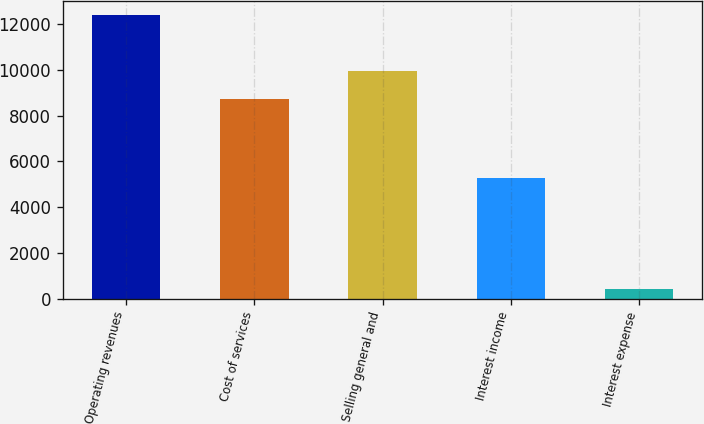<chart> <loc_0><loc_0><loc_500><loc_500><bar_chart><fcel>Operating revenues<fcel>Cost of services<fcel>Selling general and<fcel>Interest income<fcel>Interest expense<nl><fcel>12413<fcel>8740<fcel>9939.6<fcel>5267<fcel>417<nl></chart> 